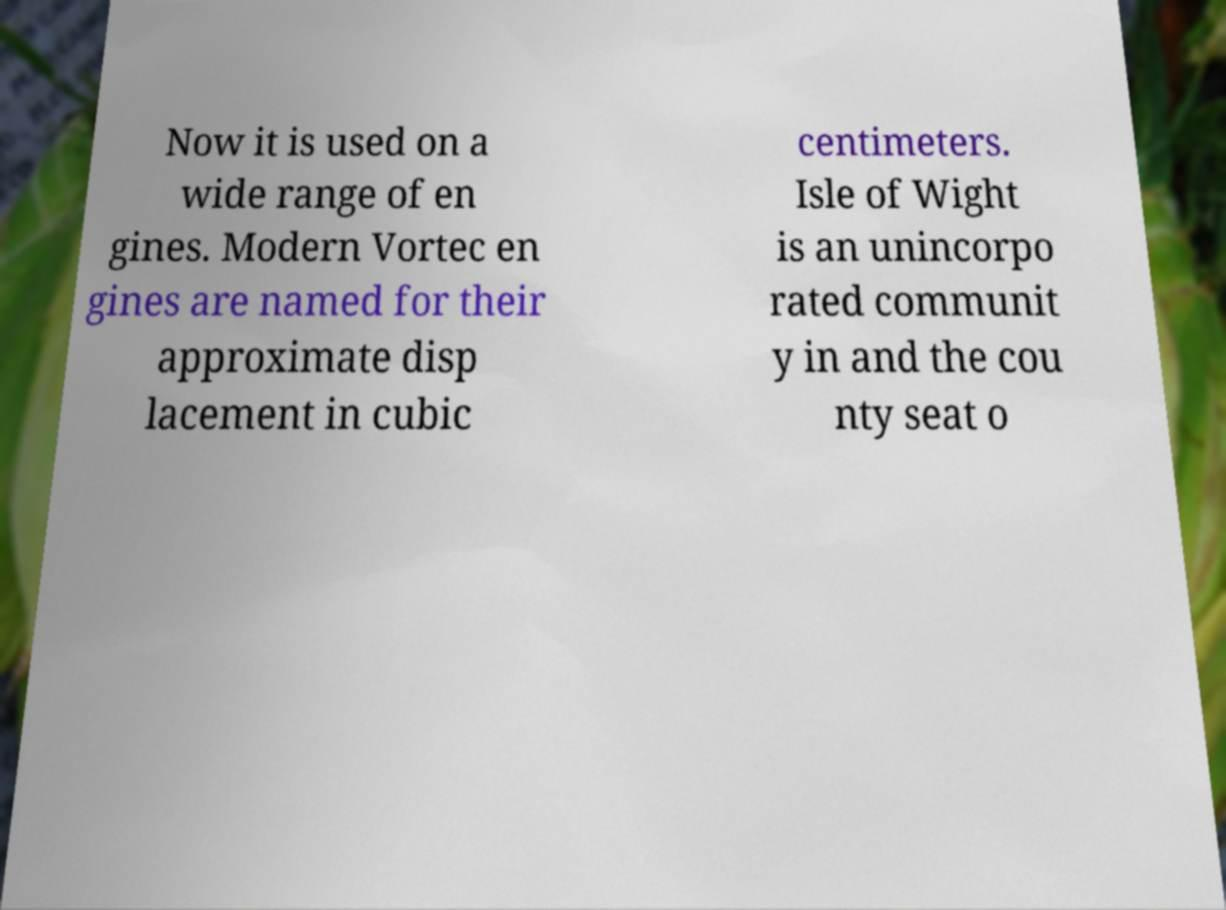Could you assist in decoding the text presented in this image and type it out clearly? Now it is used on a wide range of en gines. Modern Vortec en gines are named for their approximate disp lacement in cubic centimeters. Isle of Wight is an unincorpo rated communit y in and the cou nty seat o 